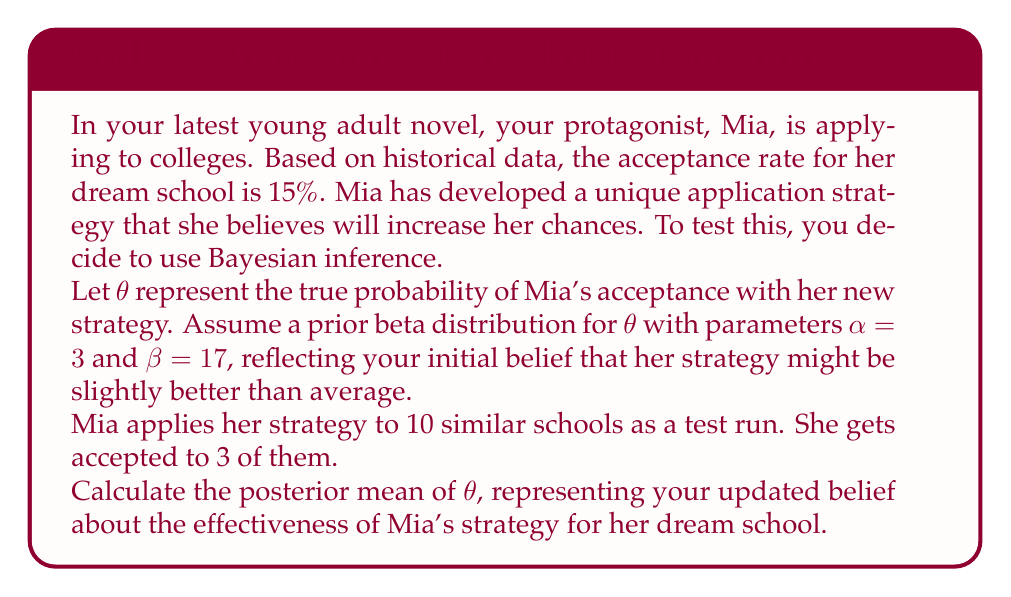Solve this math problem. To solve this problem, we'll use Bayesian inference with a beta-binomial model. The beta distribution is the conjugate prior for the binomial likelihood, which makes our calculations straightforward.

1) Prior distribution:
   We start with a Beta($\alpha=3$, $\beta=17$) prior for $\theta$.

2) Data:
   Mia applied to 10 schools and was accepted to 3.
   This gives us a binomial likelihood with $n=10$ successes and $k=3$ trials.

3) Posterior distribution:
   The posterior distribution is also a beta distribution with updated parameters:
   $$\alpha_{posterior} = \alpha_{prior} + k = 3 + 3 = 6$$
   $$\beta_{posterior} = \beta_{prior} + (n - k) = 17 + (10 - 3) = 24$$

4) Posterior mean:
   The mean of a beta distribution is given by:
   $$E[\theta] = \frac{\alpha}{\alpha + \beta}$$

   Substituting our posterior parameters:
   $$E[\theta] = \frac{\alpha_{posterior}}{\alpha_{posterior} + \beta_{posterior}} = \frac{6}{6 + 24} = \frac{6}{30} = 0.2$$

Therefore, the posterior mean of $\theta$ is 0.2 or 20%.

This result suggests that, based on the test run and our prior beliefs, Mia's strategy might indeed be more effective than the historical average (15%). However, there's still uncertainty, and more data would be needed for a more confident assessment.
Answer: The posterior mean of $\theta$ is 0.2 or 20%. 